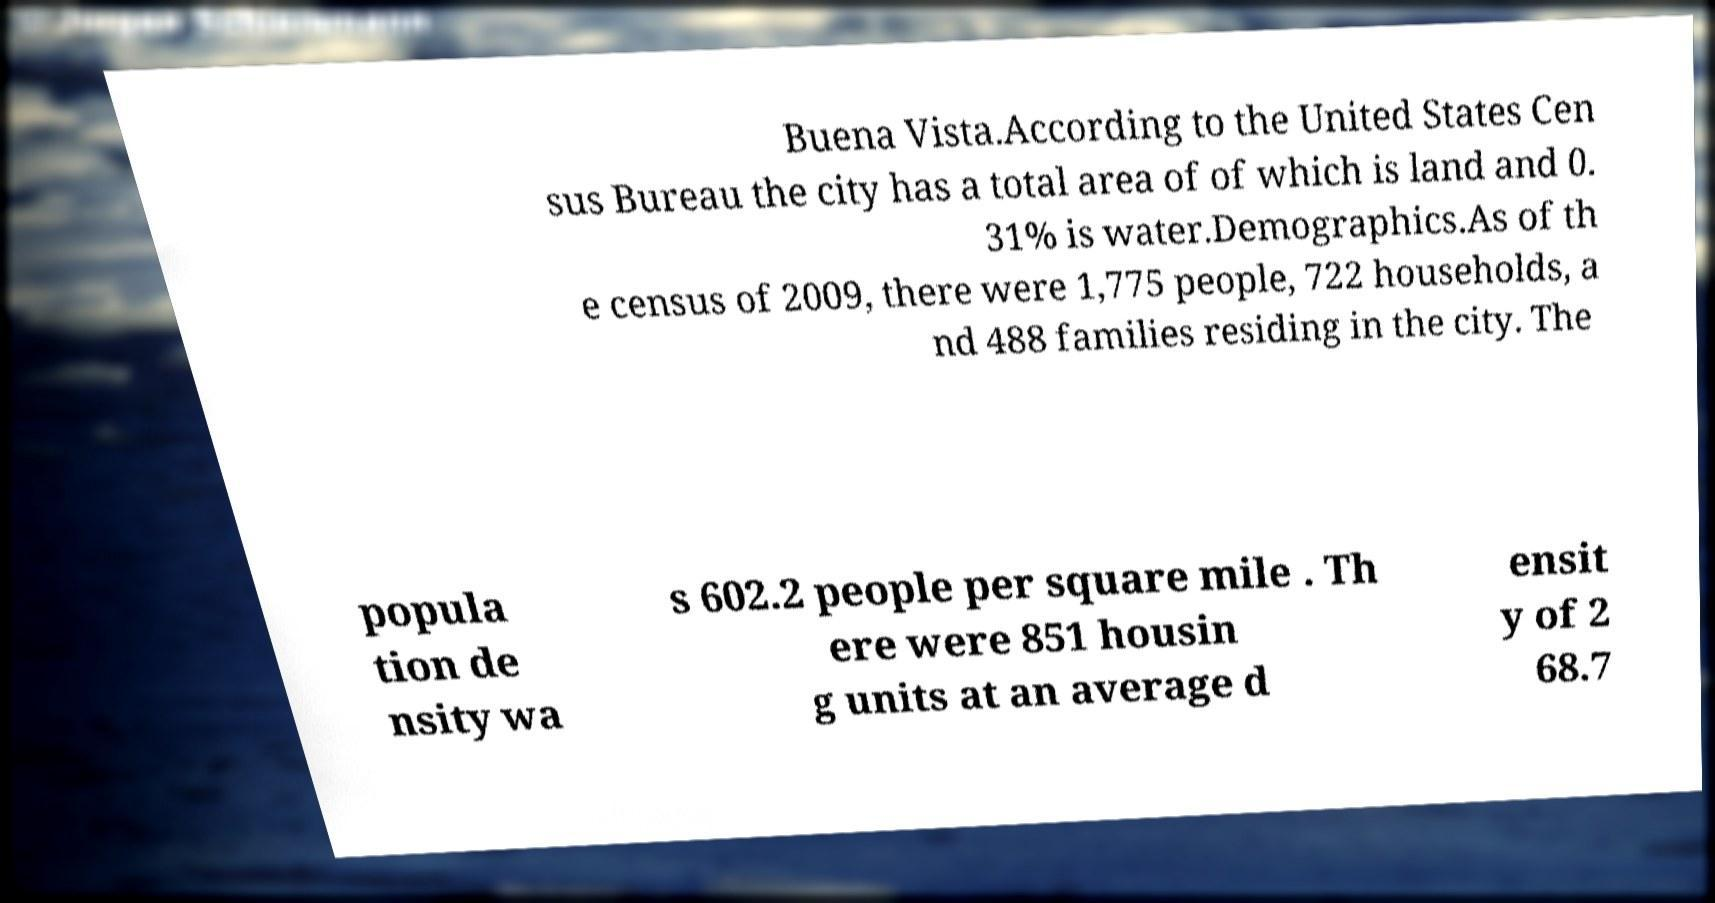Please identify and transcribe the text found in this image. Buena Vista.According to the United States Cen sus Bureau the city has a total area of of which is land and 0. 31% is water.Demographics.As of th e census of 2009, there were 1,775 people, 722 households, a nd 488 families residing in the city. The popula tion de nsity wa s 602.2 people per square mile . Th ere were 851 housin g units at an average d ensit y of 2 68.7 